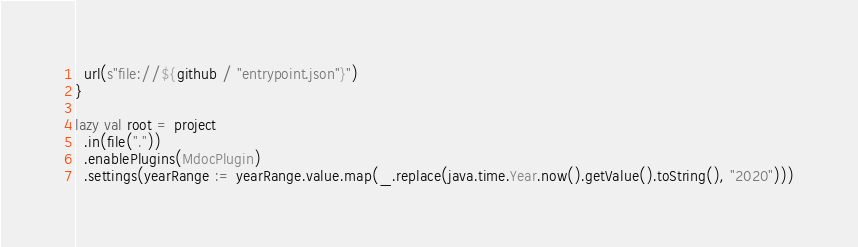<code> <loc_0><loc_0><loc_500><loc_500><_Scala_>
  url(s"file://${github / "entrypoint.json"}")
}

lazy val root = project
  .in(file("."))
  .enablePlugins(MdocPlugin)
  .settings(yearRange := yearRange.value.map(_.replace(java.time.Year.now().getValue().toString(), "2020")))
</code> 